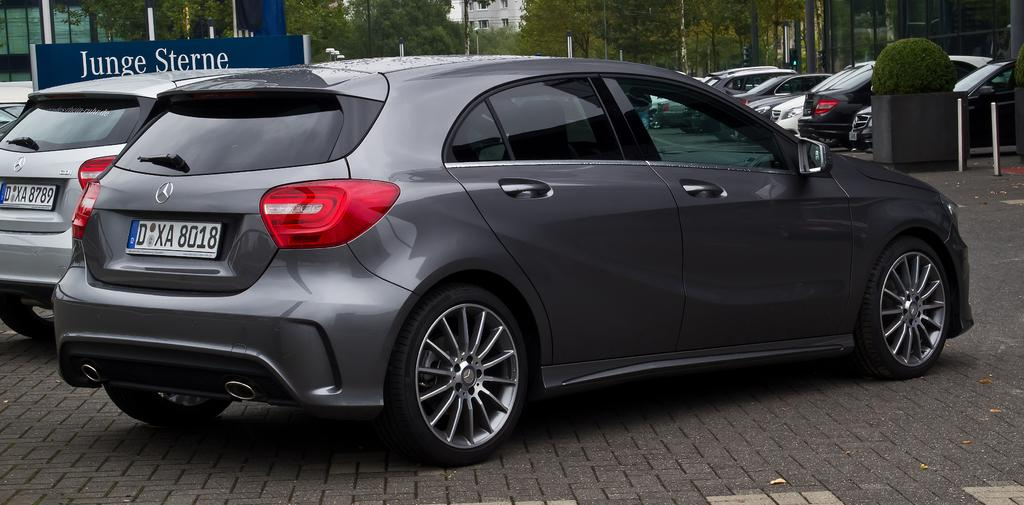What can be seen on the road in the image? There are cars on the road in the image. What is visible in the background of the image? There are trees and clouds in the background of the image. Can you describe the board with text in the image? Yes, there is a board with some text in the image. What type of fruit is being carried by the porter in the image? There is no porter present in the image, and therefore no fruit being carried. Is there any milk visible in the image? There is no milk visible in the image. 